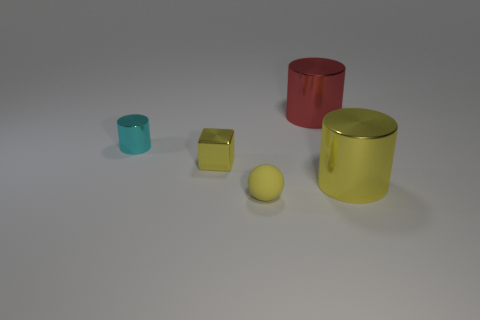Add 1 shiny things. How many objects exist? 6 Subtract all cylinders. How many objects are left? 2 Subtract all objects. Subtract all big gray shiny objects. How many objects are left? 0 Add 5 red metallic things. How many red metallic things are left? 6 Add 1 tiny gray things. How many tiny gray things exist? 1 Subtract 1 yellow balls. How many objects are left? 4 